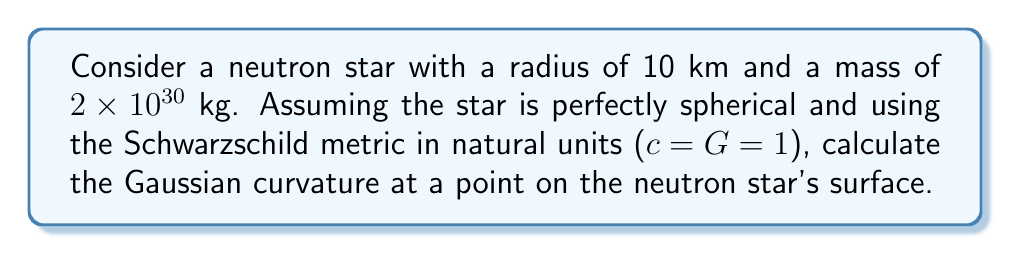Can you answer this question? To calculate the Gaussian curvature of the neutron star's surface, we'll follow these steps:

1) First, recall that for a spherically symmetric spacetime, the Schwarzschild metric in natural units is given by:

   $$ds^2 = -\left(1-\frac{2M}{r}\right)dt^2 + \left(1-\frac{2M}{r}\right)^{-1}dr^2 + r^2(d\theta^2 + \sin^2\theta d\phi^2)$$

2) The surface of the neutron star corresponds to a constant $r$ and $t$. Therefore, the induced metric on the surface is:

   $$ds^2 = r^2(d\theta^2 + \sin^2\theta d\phi^2)$$

3) This is the metric of a sphere with radius $r$. For a sphere, the Gaussian curvature $K$ is constant and given by:

   $$K = \frac{1}{r^2}$$

4) However, in General Relativity, we need to account for the curvature of spacetime. The proper radius $R$ is related to the coordinate radius $r$ by:

   $$R = \frac{r}{\sqrt{1-\frac{2M}{r}}}$$

5) Therefore, the Gaussian curvature is:

   $$K = \frac{1}{R^2} = \frac{1-\frac{2M}{r}}{r^2}$$

6) Now, let's plug in our values:
   $r = 10 \text{ km} = 10^4 \text{ m}$
   $M = 2 \times 10^{30} \text{ kg}$

   In natural units, mass is measured in meters, so we need to convert:
   $M = 2 \times 10^{30} \text{ kg} \times \frac{G}{c^2} \approx 1.48 \times 10^3 \text{ m}$

7) Substituting these values:

   $$K = \frac{1-\frac{2(1.48 \times 10^3)}{10^4}}{(10^4)^2} = \frac{1-0.296}{10^8} = \frac{0.704}{10^8} \text{ m}^{-2}$$
Answer: $7.04 \times 10^{-9} \text{ m}^{-2}$ 